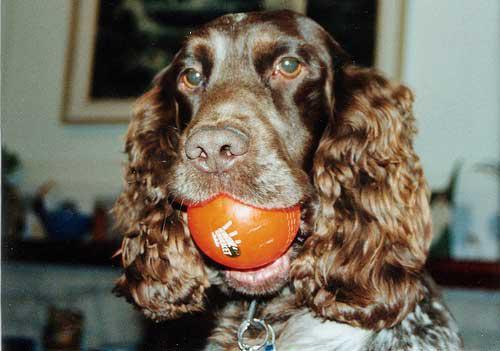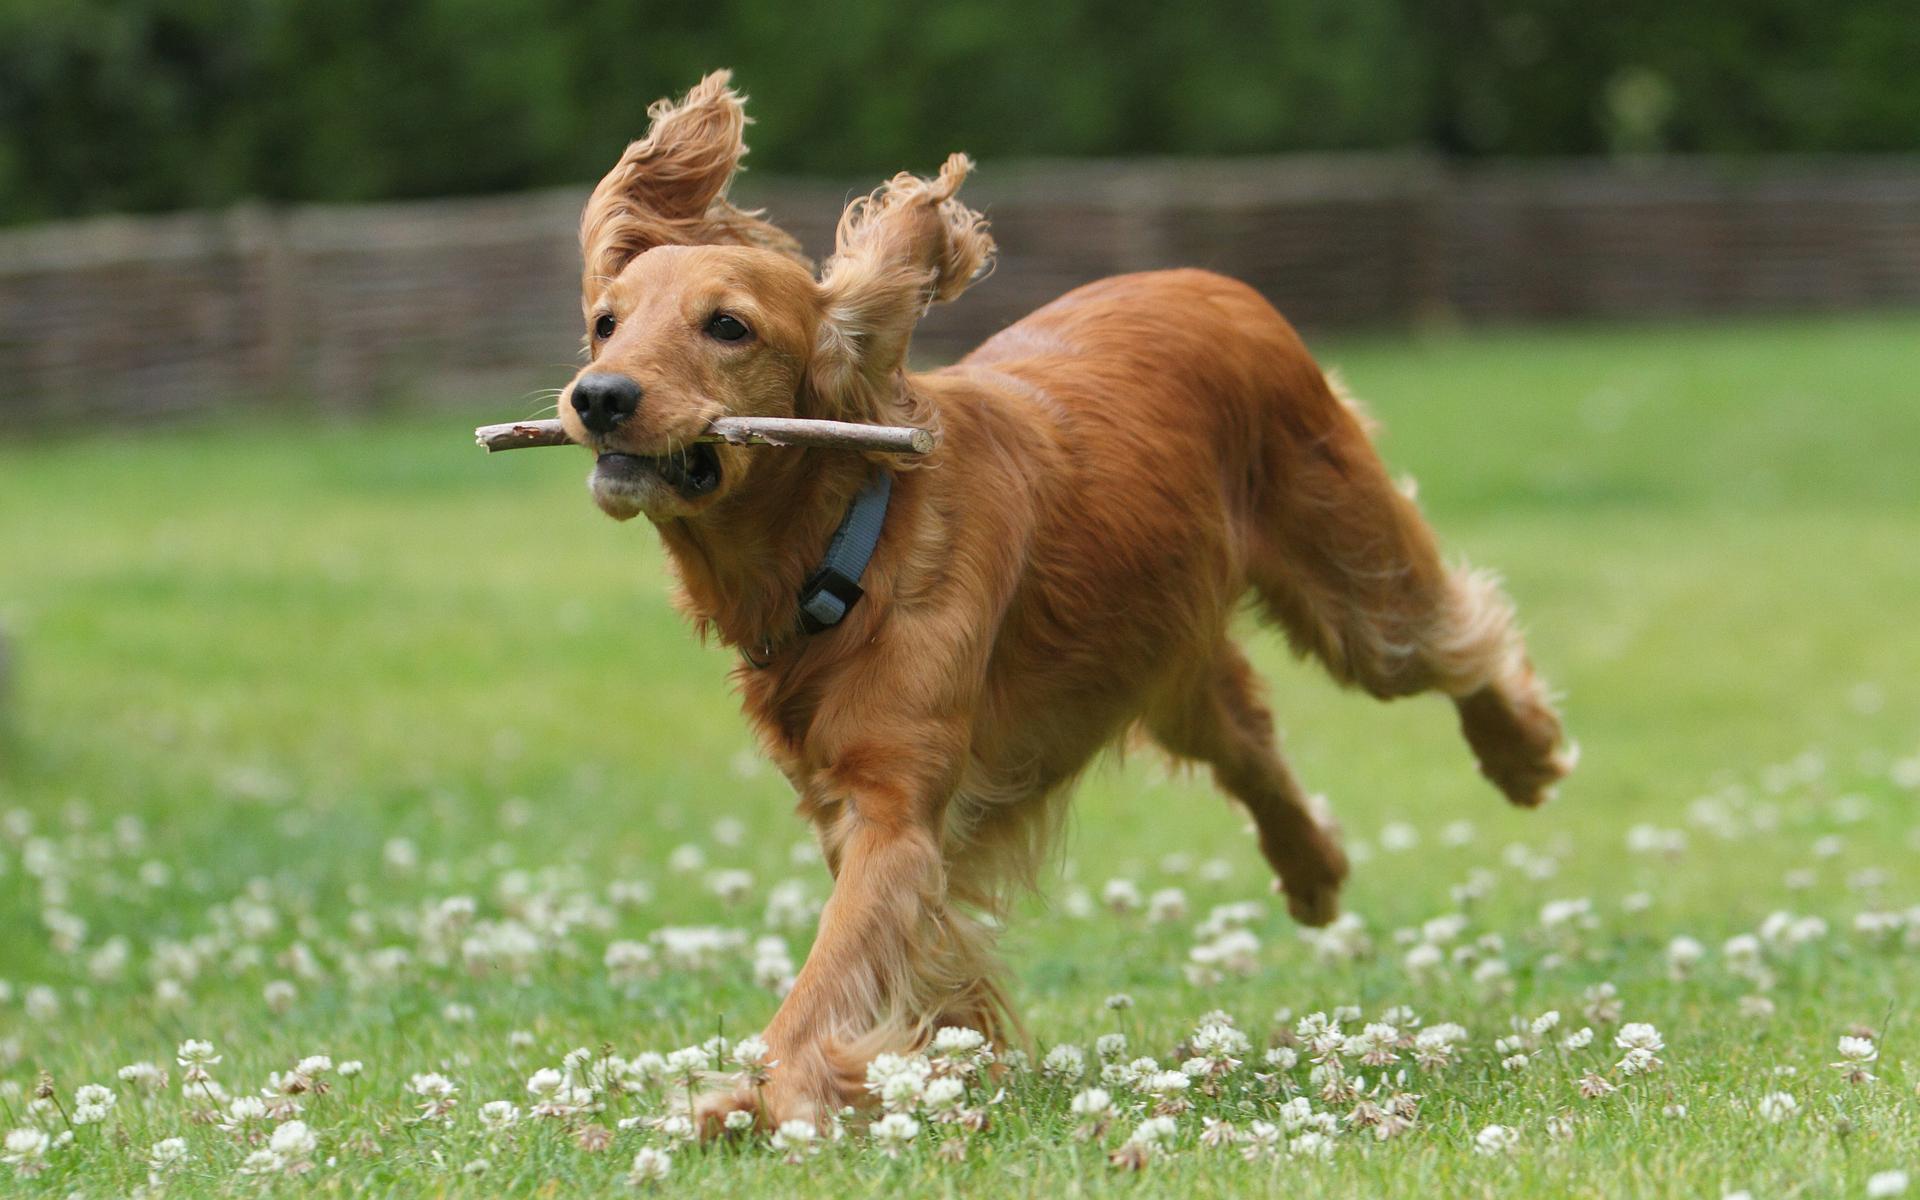The first image is the image on the left, the second image is the image on the right. Analyze the images presented: Is the assertion "The right image contains no more than one dog." valid? Answer yes or no. Yes. The first image is the image on the left, the second image is the image on the right. Evaluate the accuracy of this statement regarding the images: "Two dogs are playing in the grass in the left image, and the right image includes an orange spaniel with an open mouth.". Is it true? Answer yes or no. No. 